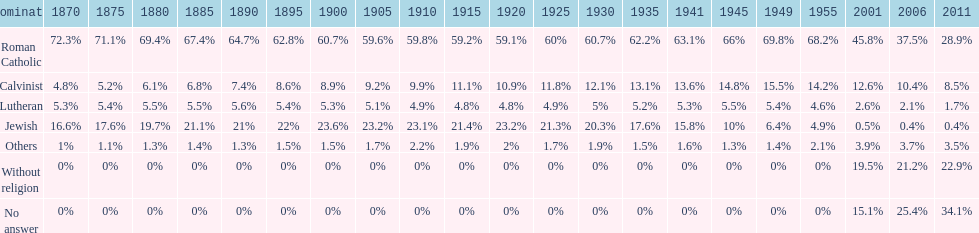What is the total percentage of people who identified as religious in 2011? 43%. 